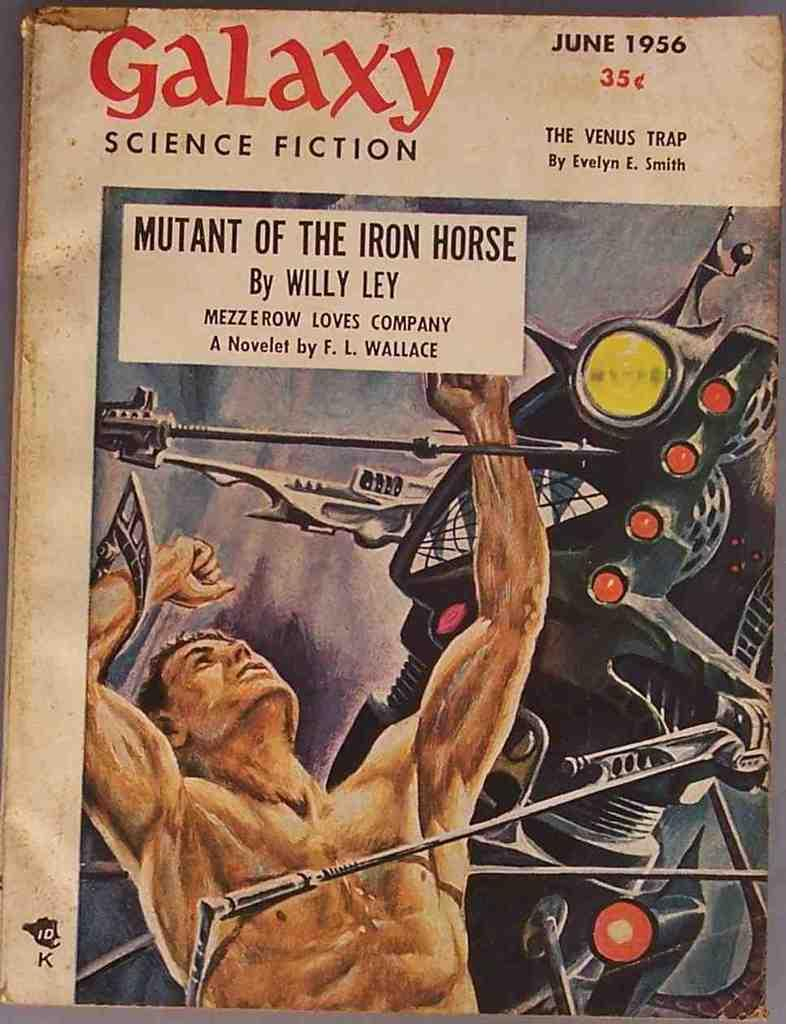What is the main subject of the image? A: The image contains the cover page of a book. What can be seen on the cover page? The cover page has a picture of a person and a statue. Is there any text on the cover page? Yes, there is text on the cover page. Where is the cover page located? The cover page is placed on a table. How many snails can be seen crawling on the cover page? There are no snails visible on the cover page; it features a picture of a person and a statue, along with text. What type of cherry is depicted in the picture of the statue? There is no cherry present in the image, as it features a picture of a person and a statue, along with text. 